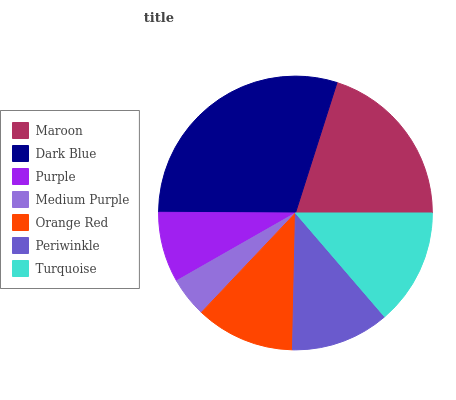Is Medium Purple the minimum?
Answer yes or no. Yes. Is Dark Blue the maximum?
Answer yes or no. Yes. Is Purple the minimum?
Answer yes or no. No. Is Purple the maximum?
Answer yes or no. No. Is Dark Blue greater than Purple?
Answer yes or no. Yes. Is Purple less than Dark Blue?
Answer yes or no. Yes. Is Purple greater than Dark Blue?
Answer yes or no. No. Is Dark Blue less than Purple?
Answer yes or no. No. Is Orange Red the high median?
Answer yes or no. Yes. Is Orange Red the low median?
Answer yes or no. Yes. Is Maroon the high median?
Answer yes or no. No. Is Medium Purple the low median?
Answer yes or no. No. 